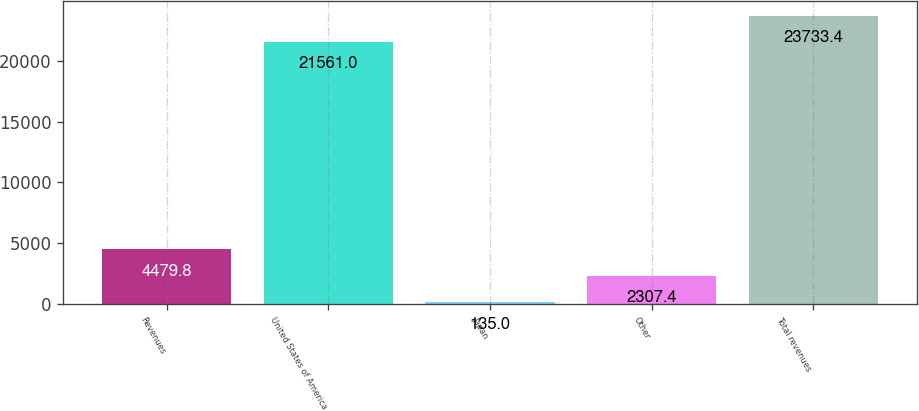<chart> <loc_0><loc_0><loc_500><loc_500><bar_chart><fcel>Revenues<fcel>United States of America<fcel>Japan<fcel>Other<fcel>Total revenues<nl><fcel>4479.8<fcel>21561<fcel>135<fcel>2307.4<fcel>23733.4<nl></chart> 